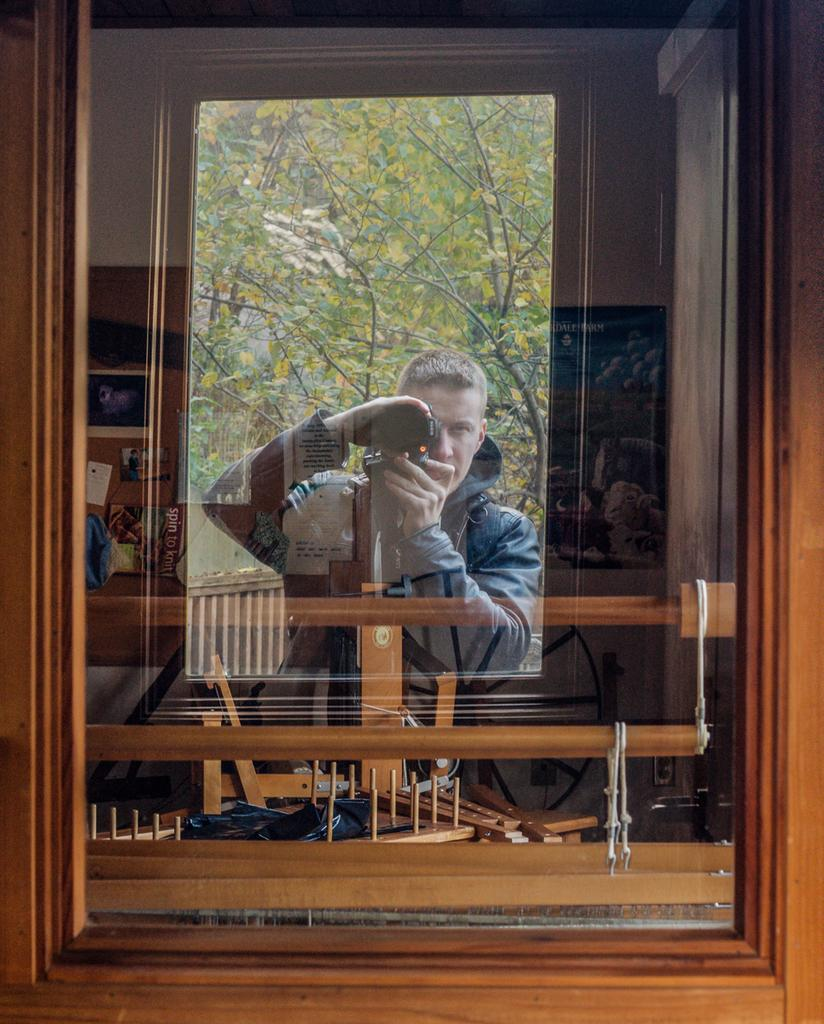What type of window is in the image? There is a glass window in the image. What can be seen through the window? A person holding a camera is visible through the window. What type of vegetation is present in the image? Trees are present in the image. What else can be seen in the image besides the window and trees? There are a few other objects in the image. What type of quartz is present in the image? There is no quartz present in the image. What is the engine's horsepower in the image? There is no engine present in the image. 